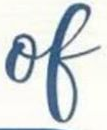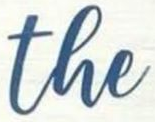Transcribe the words shown in these images in order, separated by a semicolon. of; the 